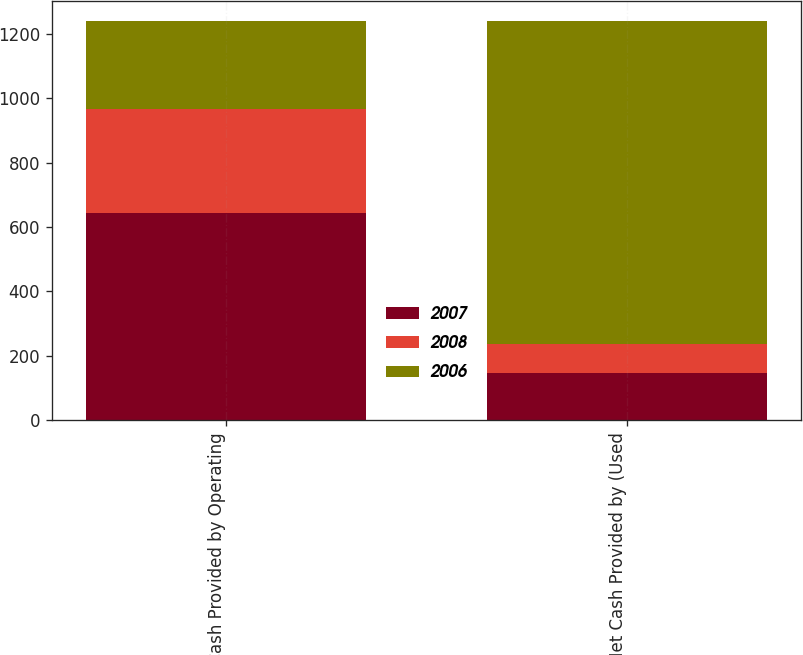<chart> <loc_0><loc_0><loc_500><loc_500><stacked_bar_chart><ecel><fcel>Net Cash Provided by Operating<fcel>Net Cash Provided by (Used<nl><fcel>2007<fcel>642.8<fcel>145.7<nl><fcel>2008<fcel>323.9<fcel>90.4<nl><fcel>2006<fcel>272.9<fcel>1002.9<nl></chart> 